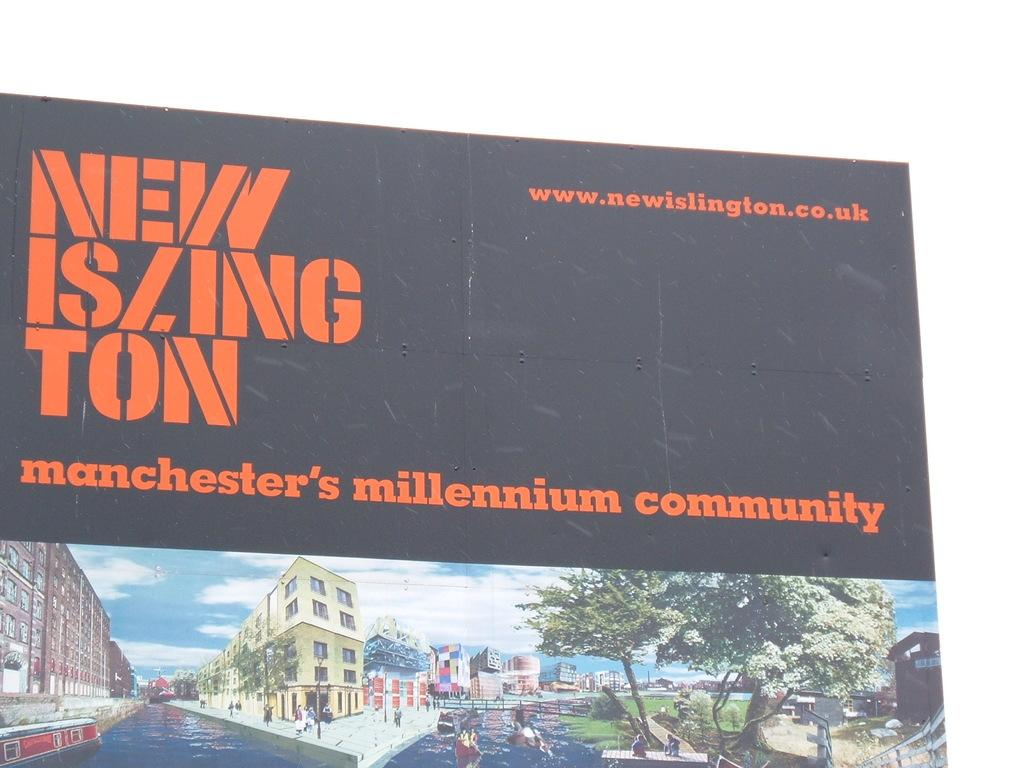<image>
Summarize the visual content of the image. Community with lake or river called Manchester's Millennium Community 